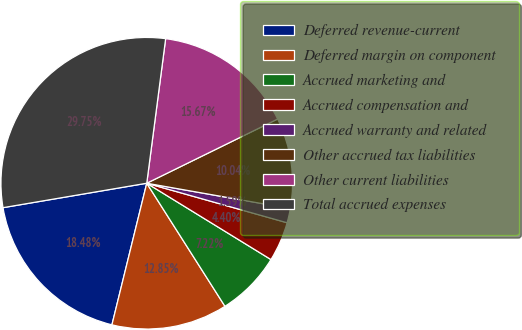Convert chart. <chart><loc_0><loc_0><loc_500><loc_500><pie_chart><fcel>Deferred revenue-current<fcel>Deferred margin on component<fcel>Accrued marketing and<fcel>Accrued compensation and<fcel>Accrued warranty and related<fcel>Other accrued tax liabilities<fcel>Other current liabilities<fcel>Total accrued expenses<nl><fcel>18.48%<fcel>12.85%<fcel>7.22%<fcel>4.4%<fcel>1.59%<fcel>10.04%<fcel>15.67%<fcel>29.75%<nl></chart> 